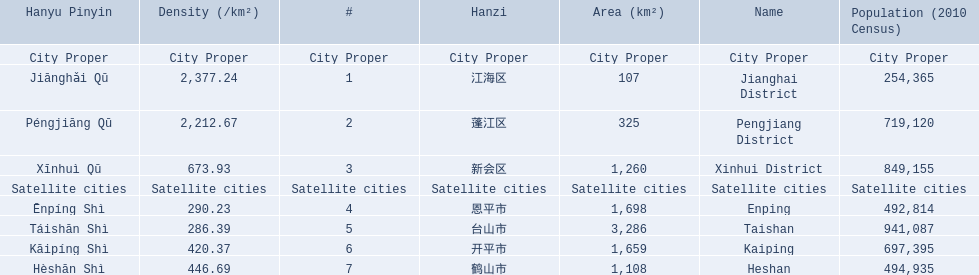What cities are there in jiangmen? Jianghai District, Pengjiang District, Xinhui District, Enping, Taishan, Kaiping, Heshan. Of those, which ones are a city proper? Jianghai District, Pengjiang District, Xinhui District. Of those, which one has the smallest area in km2? Jianghai District. 